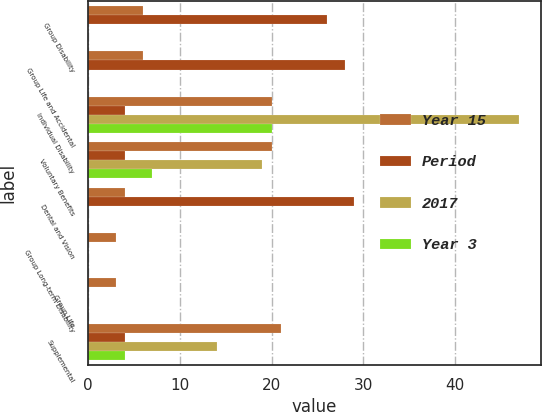Convert chart. <chart><loc_0><loc_0><loc_500><loc_500><stacked_bar_chart><ecel><fcel>Group Disability<fcel>Group Life and Accidental<fcel>Individual Disability<fcel>Voluntary Benefits<fcel>Dental and Vision<fcel>Group Long-term Disability<fcel>Group Life<fcel>Supplemental<nl><fcel>Year 15<fcel>6<fcel>6<fcel>20<fcel>20<fcel>4<fcel>3<fcel>3<fcel>21<nl><fcel>Period<fcel>26<fcel>28<fcel>4<fcel>4<fcel>29<fcel>0<fcel>0<fcel>4<nl><fcel>2017<fcel>0<fcel>0<fcel>47<fcel>19<fcel>0<fcel>0<fcel>0<fcel>14<nl><fcel>Year 3<fcel>0<fcel>0<fcel>20<fcel>7<fcel>0<fcel>0<fcel>0<fcel>4<nl></chart> 